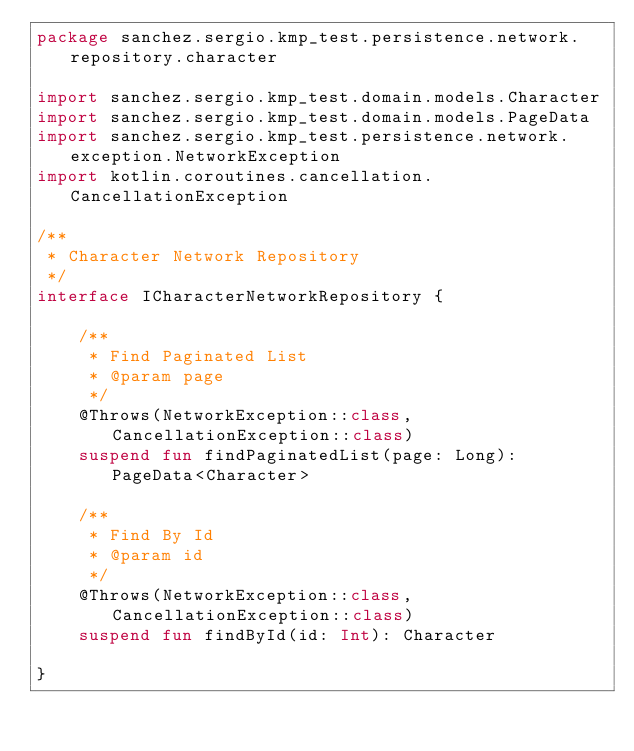<code> <loc_0><loc_0><loc_500><loc_500><_Kotlin_>package sanchez.sergio.kmp_test.persistence.network.repository.character

import sanchez.sergio.kmp_test.domain.models.Character
import sanchez.sergio.kmp_test.domain.models.PageData
import sanchez.sergio.kmp_test.persistence.network.exception.NetworkException
import kotlin.coroutines.cancellation.CancellationException

/**
 * Character Network Repository
 */
interface ICharacterNetworkRepository {

    /**
     * Find Paginated List
     * @param page
     */
    @Throws(NetworkException::class, CancellationException::class)
    suspend fun findPaginatedList(page: Long): PageData<Character>

    /**
     * Find By Id
     * @param id
     */
    @Throws(NetworkException::class, CancellationException::class)
    suspend fun findById(id: Int): Character

}</code> 